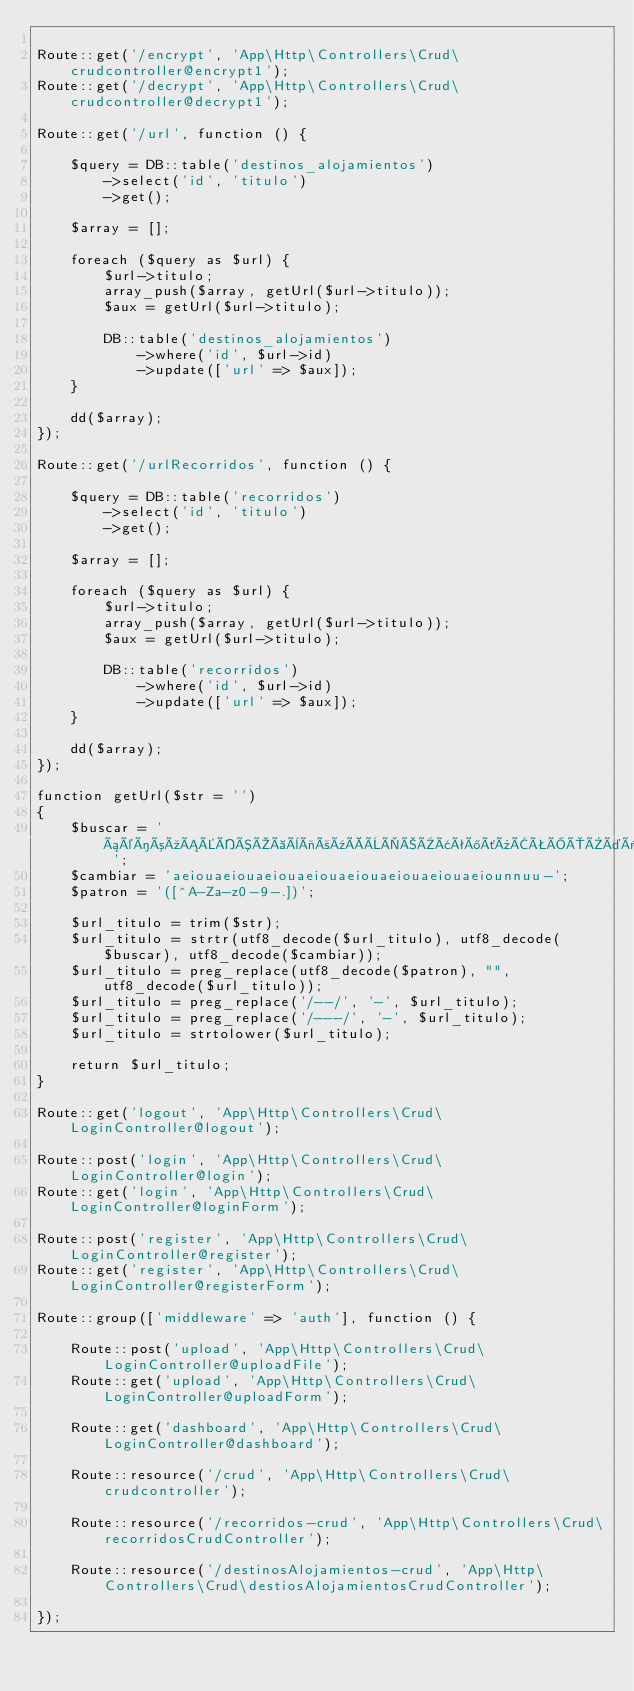Convert code to text. <code><loc_0><loc_0><loc_500><loc_500><_PHP_>
Route::get('/encrypt', 'App\Http\Controllers\Crud\crudcontroller@encrypt1');
Route::get('/decrypt', 'App\Http\Controllers\Crud\crudcontroller@decrypt1');

Route::get('/url', function () {

    $query = DB::table('destinos_alojamientos')
        ->select('id', 'titulo')
        ->get();

    $array = [];

    foreach ($query as $url) {
        $url->titulo;
        array_push($array, getUrl($url->titulo));
        $aux = getUrl($url->titulo);

        DB::table('destinos_alojamientos')
            ->where('id', $url->id)
            ->update(['url' => $aux]);
    }

    dd($array);
});

Route::get('/urlRecorridos', function () {

    $query = DB::table('recorridos')
        ->select('id', 'titulo')
        ->get();

    $array = [];

    foreach ($query as $url) {
        $url->titulo;
        array_push($array, getUrl($url->titulo));
        $aux = getUrl($url->titulo);

        DB::table('recorridos')
            ->where('id', $url->id)
            ->update(['url' => $aux]);
    }

    dd($array);
});

function getUrl($str = '')
{
    $buscar = 'áéíóúÁÉÍÓÚàèìòùÀÈÌÒÙâêîôûÂÊÎÔÛäëïöüÄËÏÖÜñÑÜü ';
    $cambiar = 'aeiouaeiouaeiouaeiouaeiouaeiouaeiouaeiounnuu-';
    $patron = '([^A-Za-z0-9-.])';

    $url_titulo = trim($str);
    $url_titulo = strtr(utf8_decode($url_titulo), utf8_decode($buscar), utf8_decode($cambiar));
    $url_titulo = preg_replace(utf8_decode($patron), "", utf8_decode($url_titulo));
    $url_titulo = preg_replace('/--/', '-', $url_titulo);
    $url_titulo = preg_replace('/---/', '-', $url_titulo);
    $url_titulo = strtolower($url_titulo);

    return $url_titulo;
}

Route::get('logout', 'App\Http\Controllers\Crud\LoginController@logout');

Route::post('login', 'App\Http\Controllers\Crud\LoginController@login');
Route::get('login', 'App\Http\Controllers\Crud\LoginController@loginForm');

Route::post('register', 'App\Http\Controllers\Crud\LoginController@register');
Route::get('register', 'App\Http\Controllers\Crud\LoginController@registerForm');

Route::group(['middleware' => 'auth'], function () {

    Route::post('upload', 'App\Http\Controllers\Crud\LoginController@uploadFile');
    Route::get('upload', 'App\Http\Controllers\Crud\LoginController@uploadForm');

    Route::get('dashboard', 'App\Http\Controllers\Crud\LoginController@dashboard');

    Route::resource('/crud', 'App\Http\Controllers\Crud\crudcontroller');

    Route::resource('/recorridos-crud', 'App\Http\Controllers\Crud\recorridosCrudController');

    Route::resource('/destinosAlojamientos-crud', 'App\Http\Controllers\Crud\destiosAlojamientosCrudController');

});
</code> 